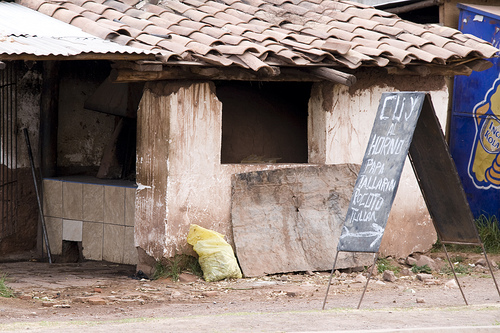<image>
Is the sign next to the building? Yes. The sign is positioned adjacent to the building, located nearby in the same general area. 